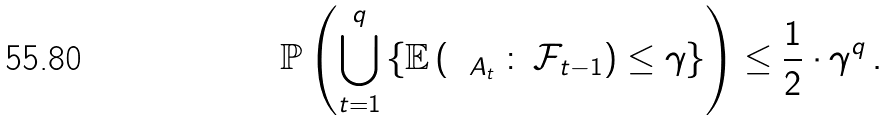Convert formula to latex. <formula><loc_0><loc_0><loc_500><loc_500>\mathbb { P } \left ( \bigcup _ { t = 1 } ^ { q } \left \{ \mathbb { E } \left ( \mathbf 1 _ { A _ { t } } \, \colon \, \mathcal { F } _ { t - 1 } \right ) \leq \gamma \right \} \right ) \leq \frac { 1 } { 2 } \cdot \gamma ^ { q } \, .</formula> 